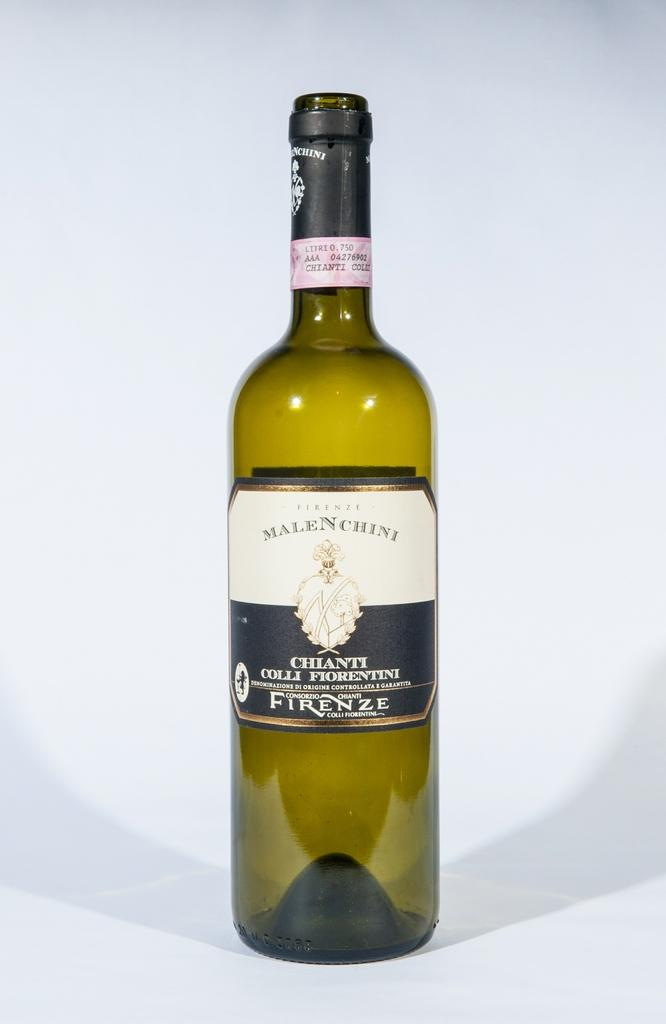<image>
Give a short and clear explanation of the subsequent image. A bottle of Chianti placed on a light blue surface. 